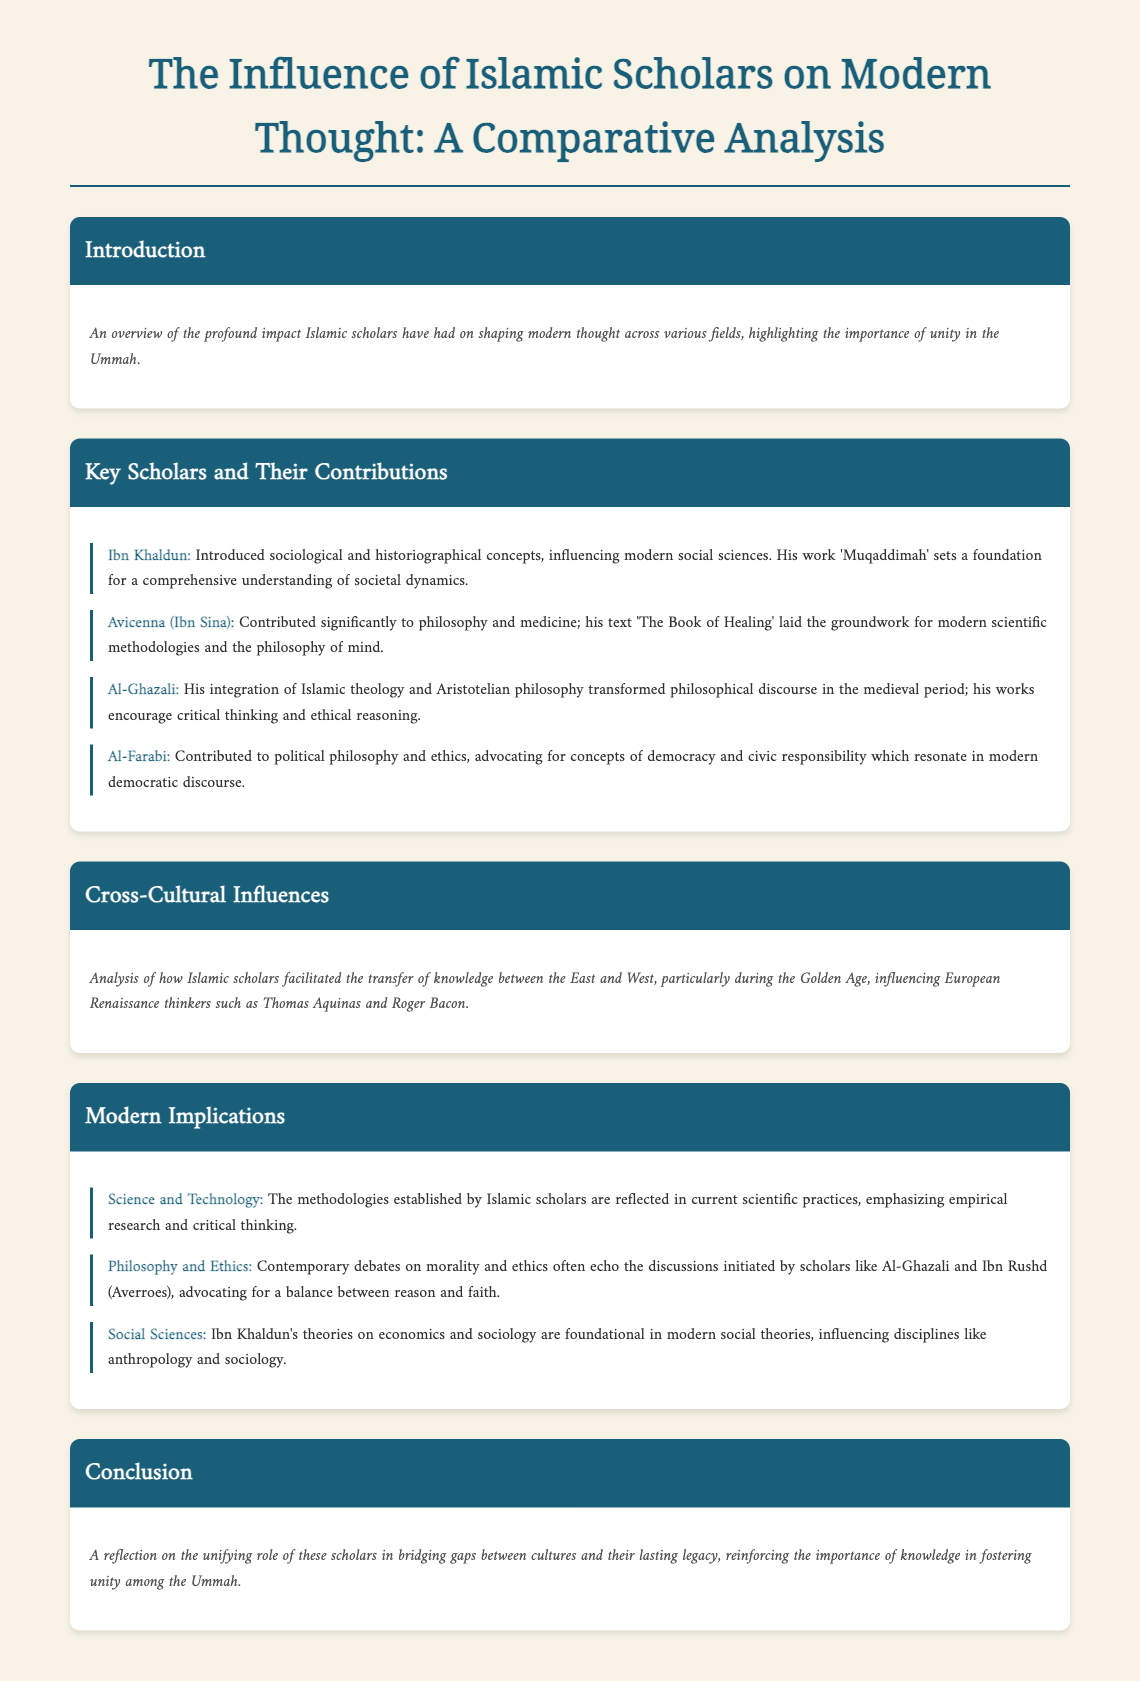What is the title of the document? The title of the document is the main heading at the top, summarizing the content it covers.
Answer: The Influence of Islamic Scholars on Modern Thought: A Comparative Analysis Who is the scholar associated with 'Muqaddimah'? This scholar is mainly known for introducing sociological concepts and is highlighted in the section regarding key scholars.
Answer: Ibn Khaldun What are the two areas of contribution mentioned for Avicenna (Ibn Sina)? These areas of contribution are detailed in the description for the scholar in the second section of the document.
Answer: Philosophy and medicine Which philosophical concept did Al-Ghazali integrate into Islamic theology? The concept is noted in the description of Al-Ghazali's contribution and its impact on philosophical discourse.
Answer: Aristotelian philosophy What influence did Islamic scholars have on the European Renaissance? This influence is discussed in the section regarding cross-cultural influences, reflecting on knowledge transfer.
Answer: Knowledge transfer What methodology is emphasized in modern scientific practices, influenced by Islamic scholars? This emphasis is outlined in the modern implications section, focusing on the way knowledge is approached.
Answer: Empirical research Who advocated for a balance between reason and faith in contemporary debates? This individual’s contributions are discussed as important influences on modern philosophy and ethics.
Answer: Al-Ghazali What is highlighted as a unifying role of scholars in the document? This role connects scholars through their contributions and impacts, fostering unity.
Answer: Bridging gaps between cultures 